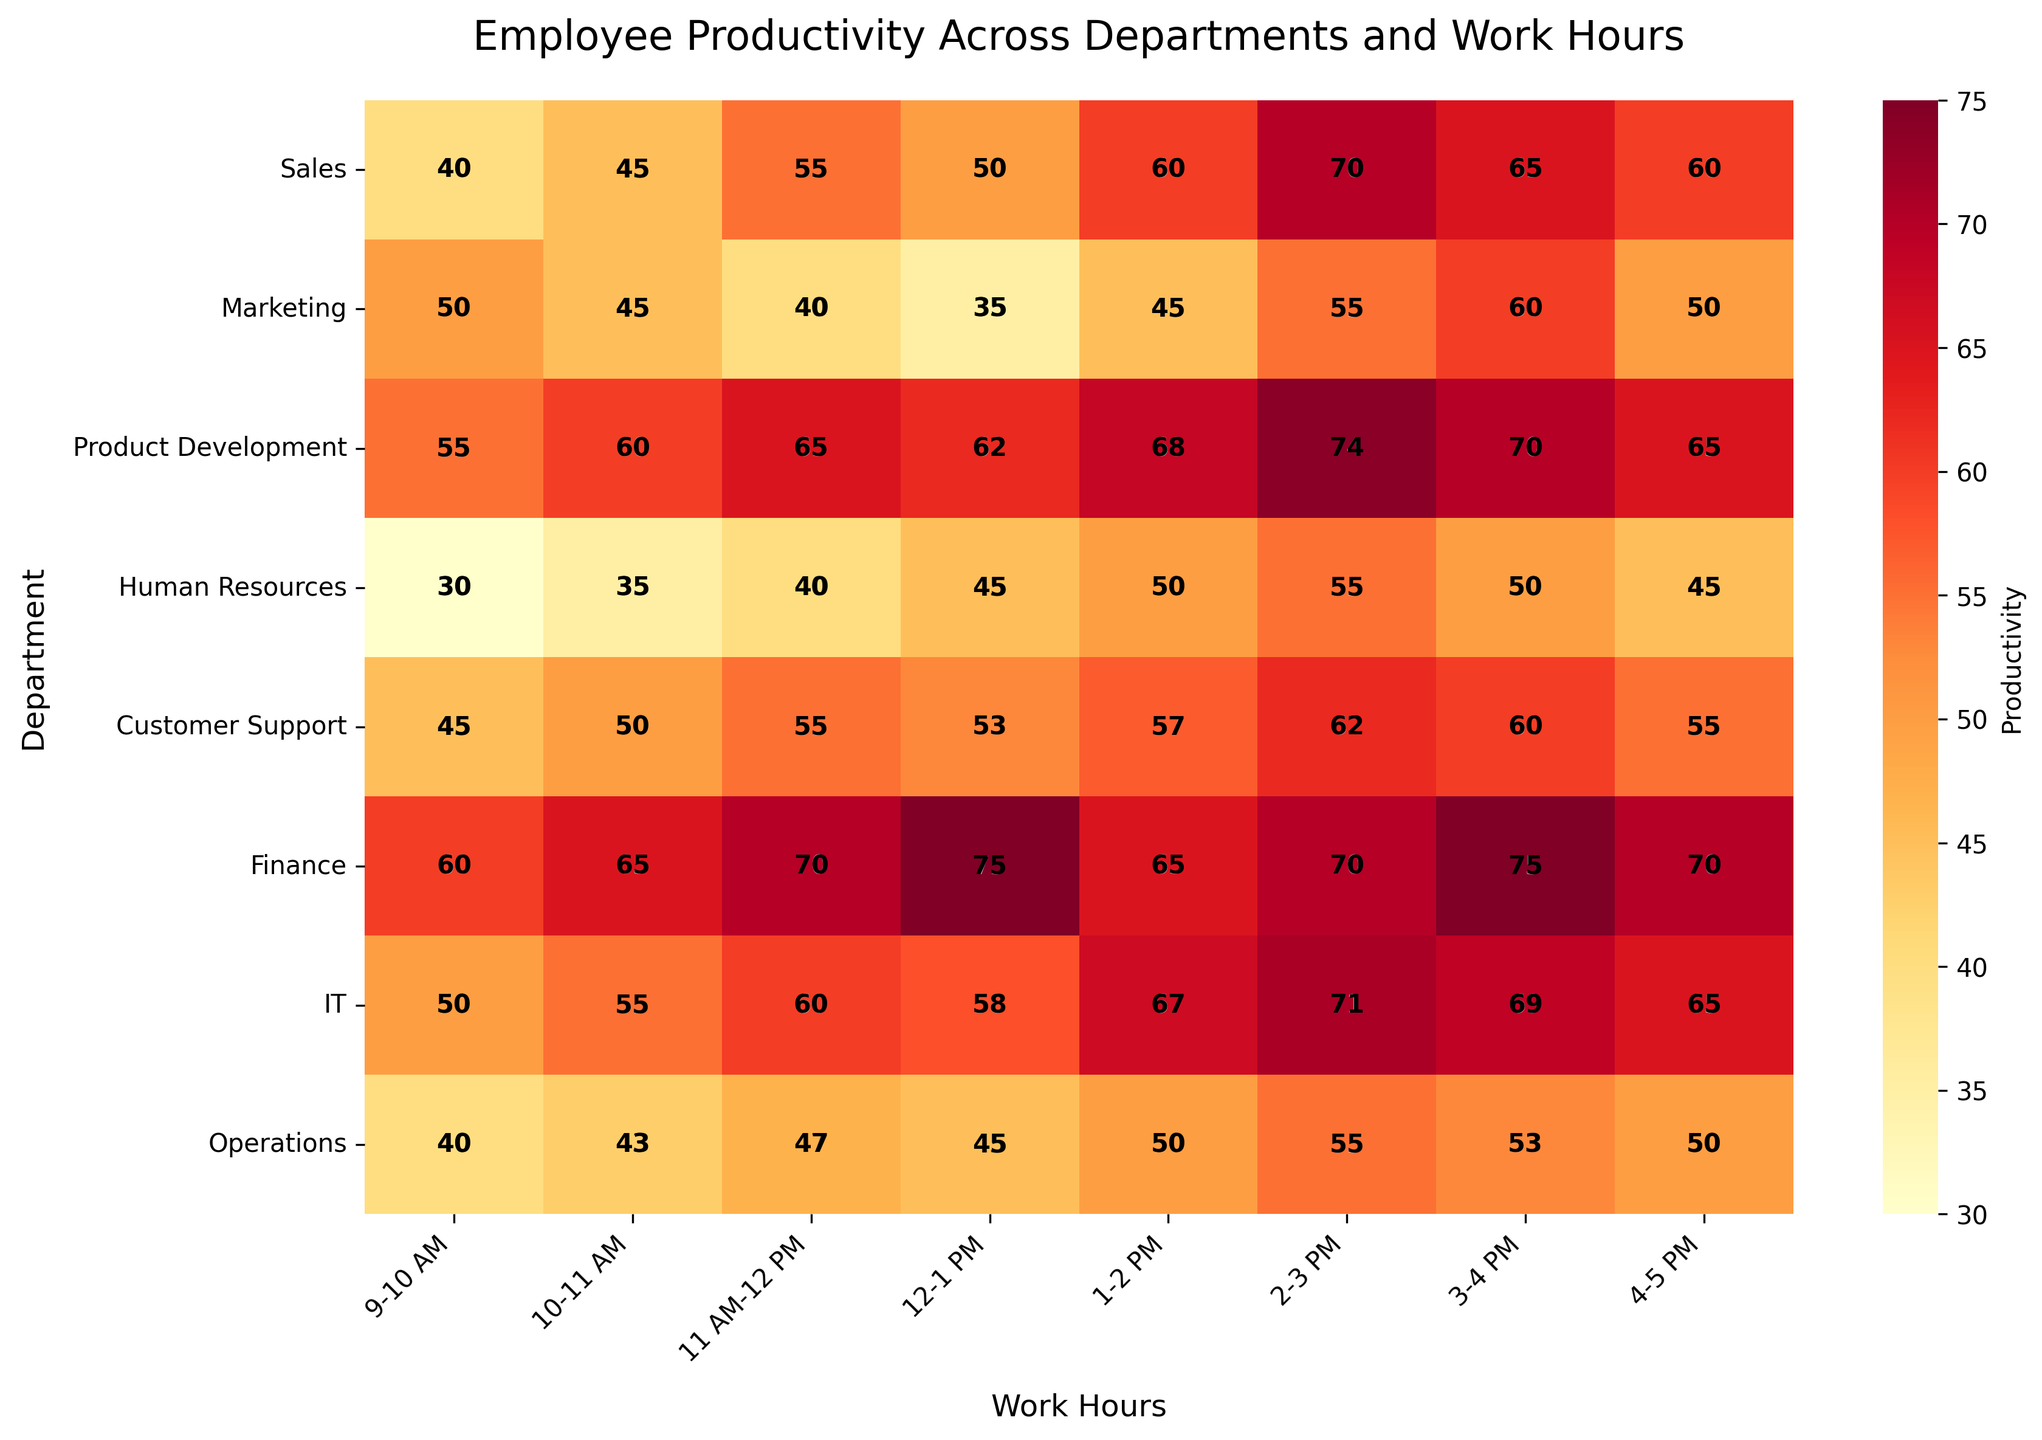What is the title of the heatmap? The title of the heatmap is found at the top of the plot. In this case, it is displayed clearly.
Answer: Employee Productivity Across Departments and Work Hours Which department shows the highest productivity at 1-2 PM? Look at the cell corresponding to the Finance department and the 1-2 PM column. The value in the cell is 75, which is the highest.
Answer: Finance How does productivity in Sales change from 9-10 AM to 4-5 PM? Observe the Sales row and note the productivity values from 9-10 AM (40) to 4-5 PM (60). There's an overall increase.
Answer: Increases Which work hour shows the highest productivity for Customer Support? In the Customer Support row, find the highest value. The highest productivity is 62, occurring from 2-3 PM.
Answer: 2-3 PM What is the average productivity of the Marketing team from 9 AM to 5 PM? Sum the values in the Marketing row (50, 45, 40, 35, 45, 55, 60, 50) and divide by the number of hours (8). The total is 380, so the average is 380/8 = 47.5.
Answer: 47.5 Which department has the least productivity at 12-1 PM and what is the value? Look at the 12-1 PM column and identify the minimum value. In this column, Human Resources shows a productivity of 45.
Answer: Human Resources, 45 Compare the productivity of IT and Product Development at 2-3 PM. Which one is higher? Check the 2-3 PM column for both IT (71) and Product Development (74), and identify which is higher.
Answer: Product Development What is the difference in productivity between Finance and Operations at 3-4 PM? Look at the 3-4 PM column for both Finance (75) and Operations (53). Calculate the difference: 75 - 53 = 22.
Answer: 22 Which department has the most consistent productivity throughout the day? Consistency can be judged by the least variation. Comparing the rows, Sales and Human Resources show less fluctuation in values compared to others.
Answer: Sales or Human Resources What is the overall trend in productivity for the Product Development department from 9 AM to 5 PM? By observing the Product Development row, note that productivity generally increases from 9 AM to 3 PM, and then it drops slightly towards 5 PM.
Answer: Increasing then Decreasing 